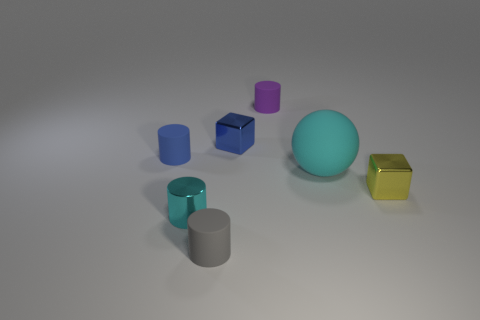There is a large cyan object; are there any big matte balls on the left side of it?
Give a very brief answer. No. How many other things are the same size as the blue matte cylinder?
Give a very brief answer. 5. There is a small thing that is both behind the tiny blue matte cylinder and on the left side of the purple object; what material is it?
Provide a succinct answer. Metal. Do the matte object in front of the cyan rubber object and the tiny shiny thing left of the blue metallic object have the same shape?
Your answer should be compact. Yes. Are there any other things that are the same material as the small gray object?
Offer a terse response. Yes. There is a small blue thing right of the metallic object that is in front of the small cube in front of the tiny blue cube; what shape is it?
Give a very brief answer. Cube. How many other things are there of the same shape as the blue matte object?
Make the answer very short. 3. There is a shiny cylinder that is the same size as the yellow metallic cube; what color is it?
Your answer should be very brief. Cyan. How many cubes are tiny blue objects or rubber objects?
Make the answer very short. 1. How many big brown metal spheres are there?
Keep it short and to the point. 0. 